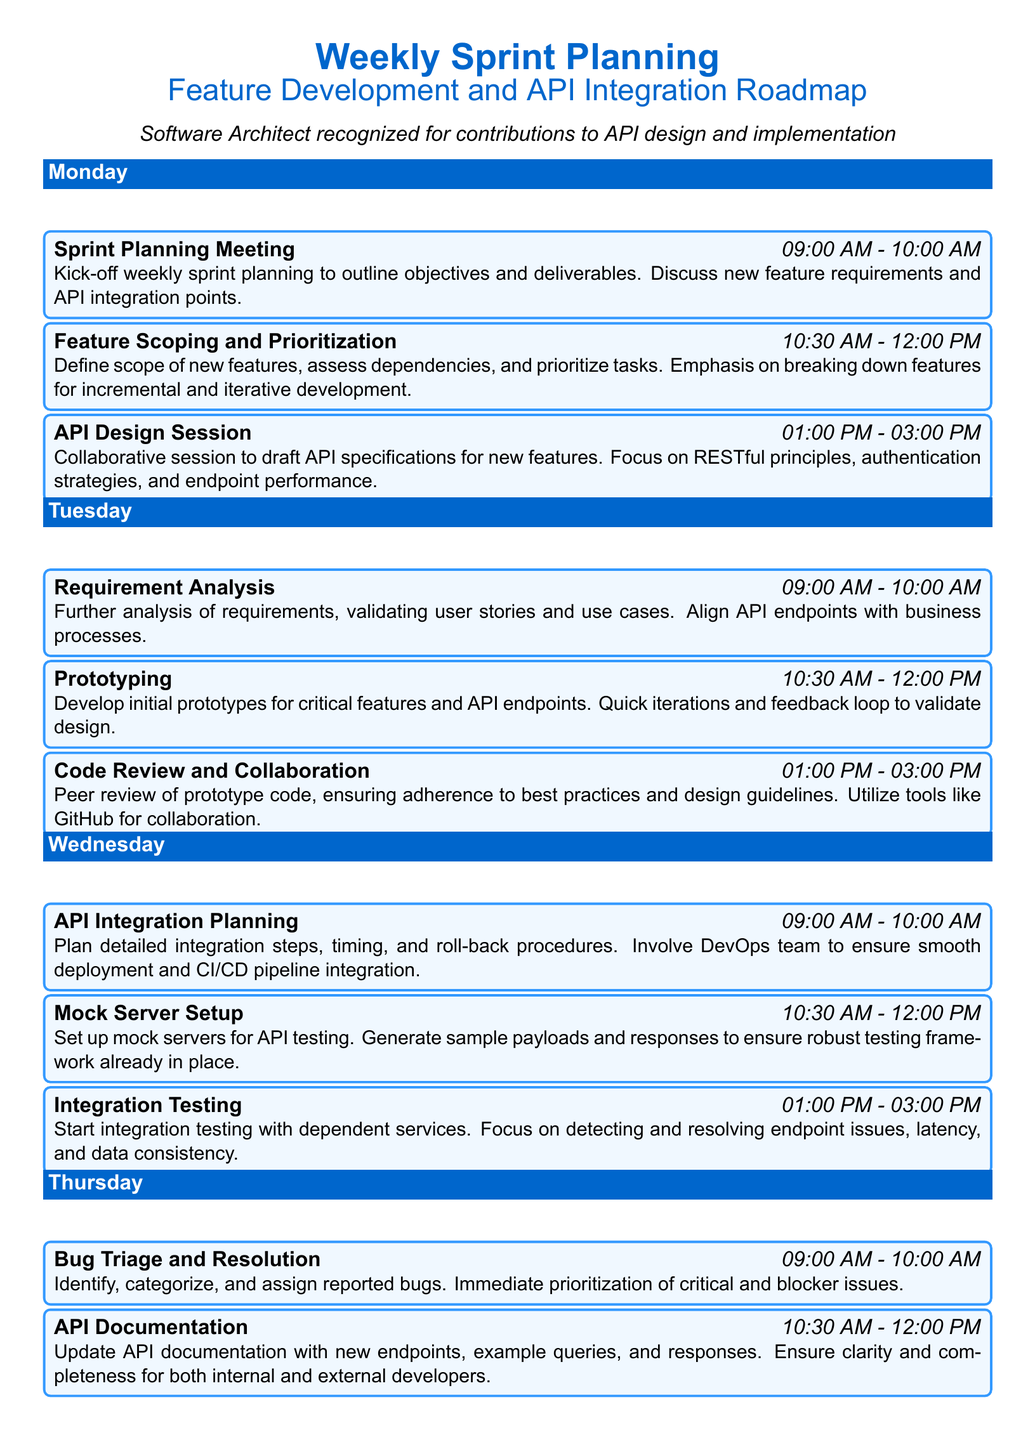What time does the Sprint Planning Meeting start? The Sprint Planning Meeting is scheduled for 09:00 AM on Monday.
Answer: 09:00 AM How long is the API Design Session on Monday? The API Design Session lasts from 01:00 PM to 03:00 PM, which is 2 hours.
Answer: 2 hours What is the focus of the Performance Optimization activity? The focus is on optimizing API endpoints for performance and identifying bottlenecks.
Answer: API performance What activity follows Requirement Analysis on Tuesday? Prototyping is the activity that follows Requirement Analysis.
Answer: Prototyping How many activities are scheduled for Friday? There are three activities scheduled for Friday, which are Final Review and Retrospection, Deployment Preparation, and Demo & Client Feedback.
Answer: Three activities Which team is involved in the API Integration Planning? The DevOps team is involved in the API Integration Planning.
Answer: DevOps team What is the primary goal of the Demo & Client Feedback session? The primary goal is to demo completed features to stakeholders and gather feedback.
Answer: Demo completed features What activity is scheduled for 10:30 AM on Thursday? The activity scheduled for 10:30 AM on Thursday is API Documentation.
Answer: API Documentation 